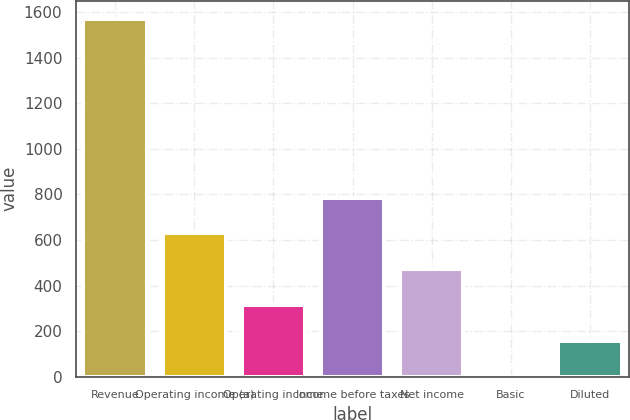<chart> <loc_0><loc_0><loc_500><loc_500><bar_chart><fcel>Revenue<fcel>Operating income (a)<fcel>Operating income<fcel>Income before taxes<fcel>Net income<fcel>Basic<fcel>Diluted<nl><fcel>1571.7<fcel>629.41<fcel>315.31<fcel>786.46<fcel>472.36<fcel>1.21<fcel>158.26<nl></chart> 